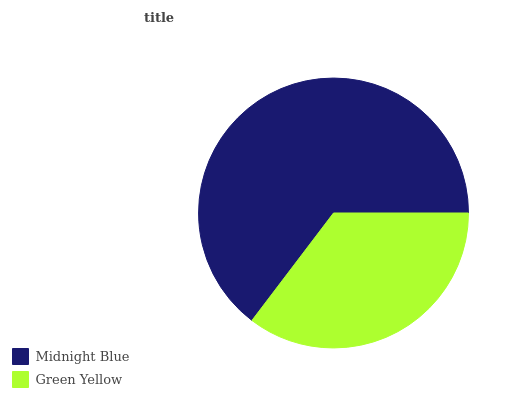Is Green Yellow the minimum?
Answer yes or no. Yes. Is Midnight Blue the maximum?
Answer yes or no. Yes. Is Green Yellow the maximum?
Answer yes or no. No. Is Midnight Blue greater than Green Yellow?
Answer yes or no. Yes. Is Green Yellow less than Midnight Blue?
Answer yes or no. Yes. Is Green Yellow greater than Midnight Blue?
Answer yes or no. No. Is Midnight Blue less than Green Yellow?
Answer yes or no. No. Is Midnight Blue the high median?
Answer yes or no. Yes. Is Green Yellow the low median?
Answer yes or no. Yes. Is Green Yellow the high median?
Answer yes or no. No. Is Midnight Blue the low median?
Answer yes or no. No. 